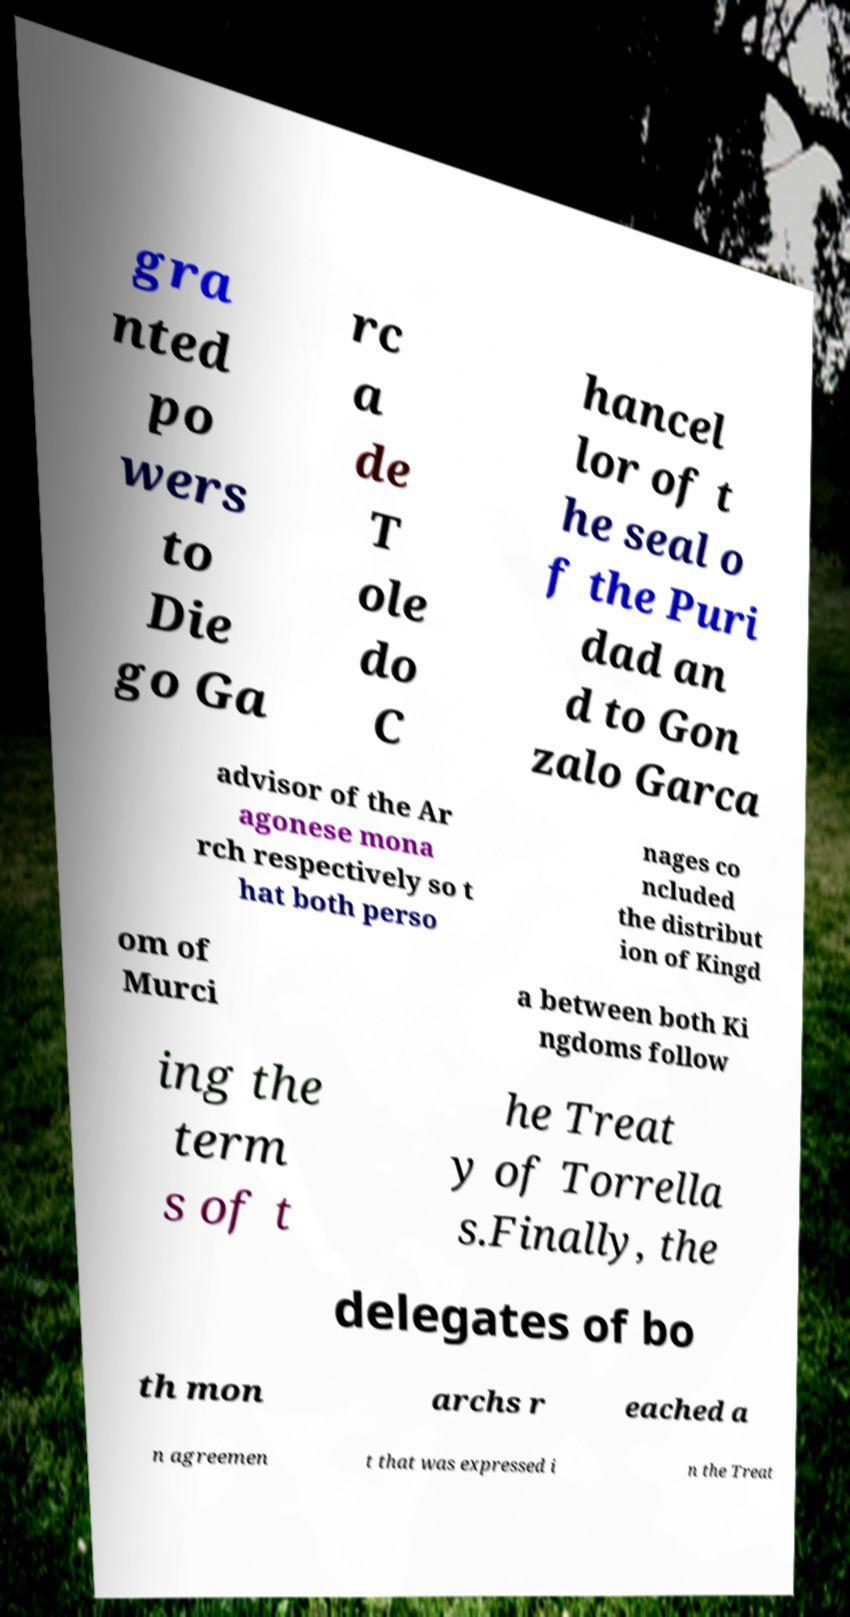What messages or text are displayed in this image? I need them in a readable, typed format. gra nted po wers to Die go Ga rc a de T ole do C hancel lor of t he seal o f the Puri dad an d to Gon zalo Garca advisor of the Ar agonese mona rch respectively so t hat both perso nages co ncluded the distribut ion of Kingd om of Murci a between both Ki ngdoms follow ing the term s of t he Treat y of Torrella s.Finally, the delegates of bo th mon archs r eached a n agreemen t that was expressed i n the Treat 